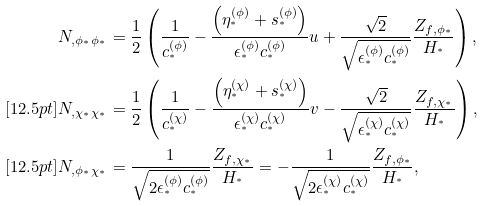<formula> <loc_0><loc_0><loc_500><loc_500>N _ { , \phi _ { ^ { * } } \phi _ { ^ { * } } } & = \frac { 1 } { 2 } \left ( \frac { 1 } { c ^ { ( \phi ) } _ { ^ { * } } } - \frac { \left ( \eta ^ { ( \phi ) } _ { ^ { * } } + s ^ { ( \phi ) } _ { ^ { * } } \right ) } { \epsilon ^ { ( \phi ) } _ { ^ { * } } c ^ { ( \phi ) } _ { ^ { * } } } u + \frac { \sqrt { 2 } } { \sqrt { \epsilon ^ { ( \phi ) } _ { ^ { * } } c ^ { ( \phi ) } _ { ^ { * } } } } \frac { Z _ { f , \phi _ { ^ { * } } } } { H _ { ^ { * } } } \right ) , \\ [ 1 2 . 5 p t ] N _ { , \chi _ { ^ { * } } \chi _ { ^ { * } } } & = \frac { 1 } { 2 } \left ( \frac { 1 } { c ^ { ( \chi ) } _ { ^ { * } } } - \frac { \left ( \eta ^ { ( \chi ) } _ { ^ { * } } + s ^ { ( \chi ) } _ { ^ { * } } \right ) } { \epsilon ^ { ( \chi ) } _ { ^ { * } } c ^ { ( \chi ) } _ { ^ { * } } } v - \frac { \sqrt { 2 } } { \sqrt { \epsilon ^ { ( \chi ) } _ { ^ { * } } c ^ { ( \chi ) } _ { ^ { * } } } } \frac { Z _ { f , \chi _ { ^ { * } } } } { H _ { ^ { * } } } \right ) , \\ [ 1 2 . 5 p t ] N _ { , \phi _ { ^ { * } } \chi _ { ^ { * } } } & = \frac { 1 } { \sqrt { 2 \epsilon ^ { ( \phi ) } _ { ^ { * } } c ^ { ( \phi ) } _ { ^ { * } } } } \frac { Z _ { f , \chi _ { ^ { * } } } } { H _ { ^ { * } } } = - \frac { 1 } { \sqrt { 2 \epsilon ^ { ( \chi ) } _ { ^ { * } } c ^ { ( \chi ) } _ { ^ { * } } } } \frac { Z _ { f , \phi _ { ^ { * } } } } { H _ { ^ { * } } } ,</formula> 